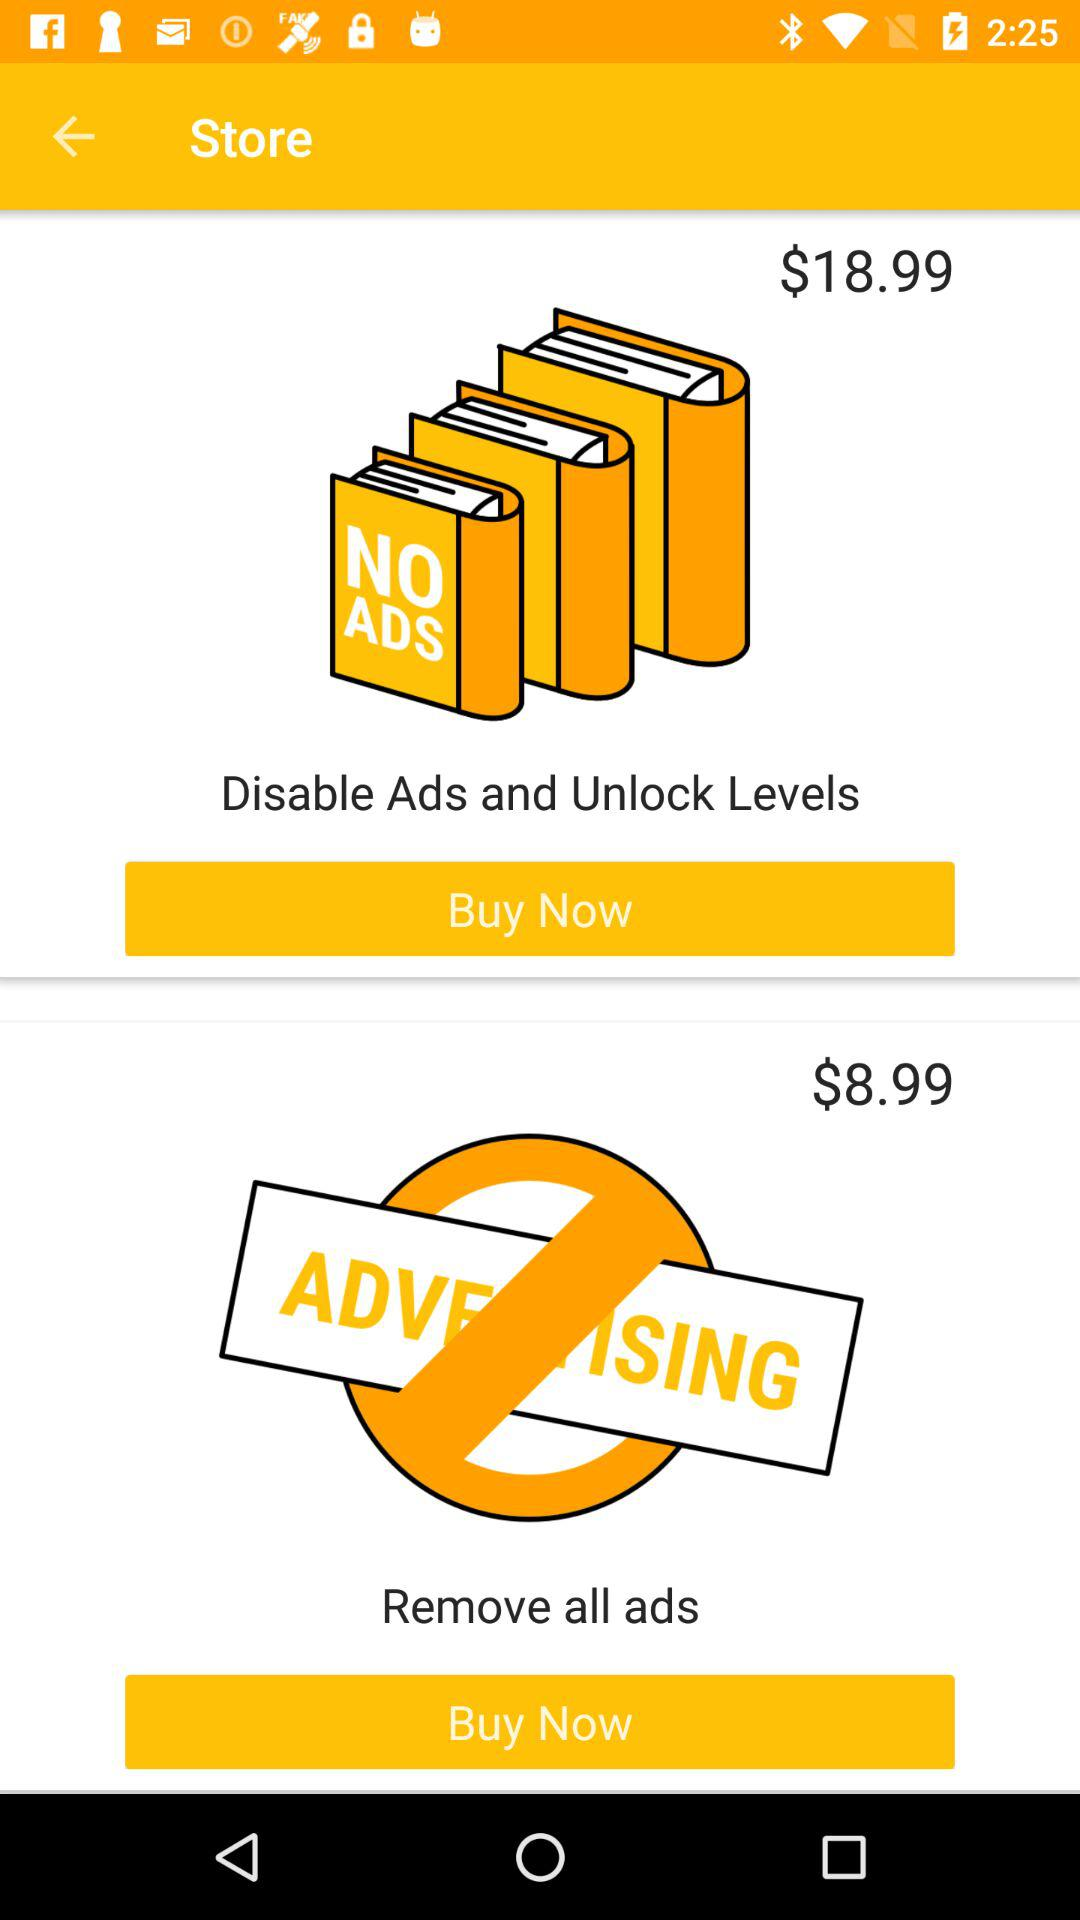What is the price to disable advertising and unlock levels? The price to disable advertising and unlock levels is $18.99. 